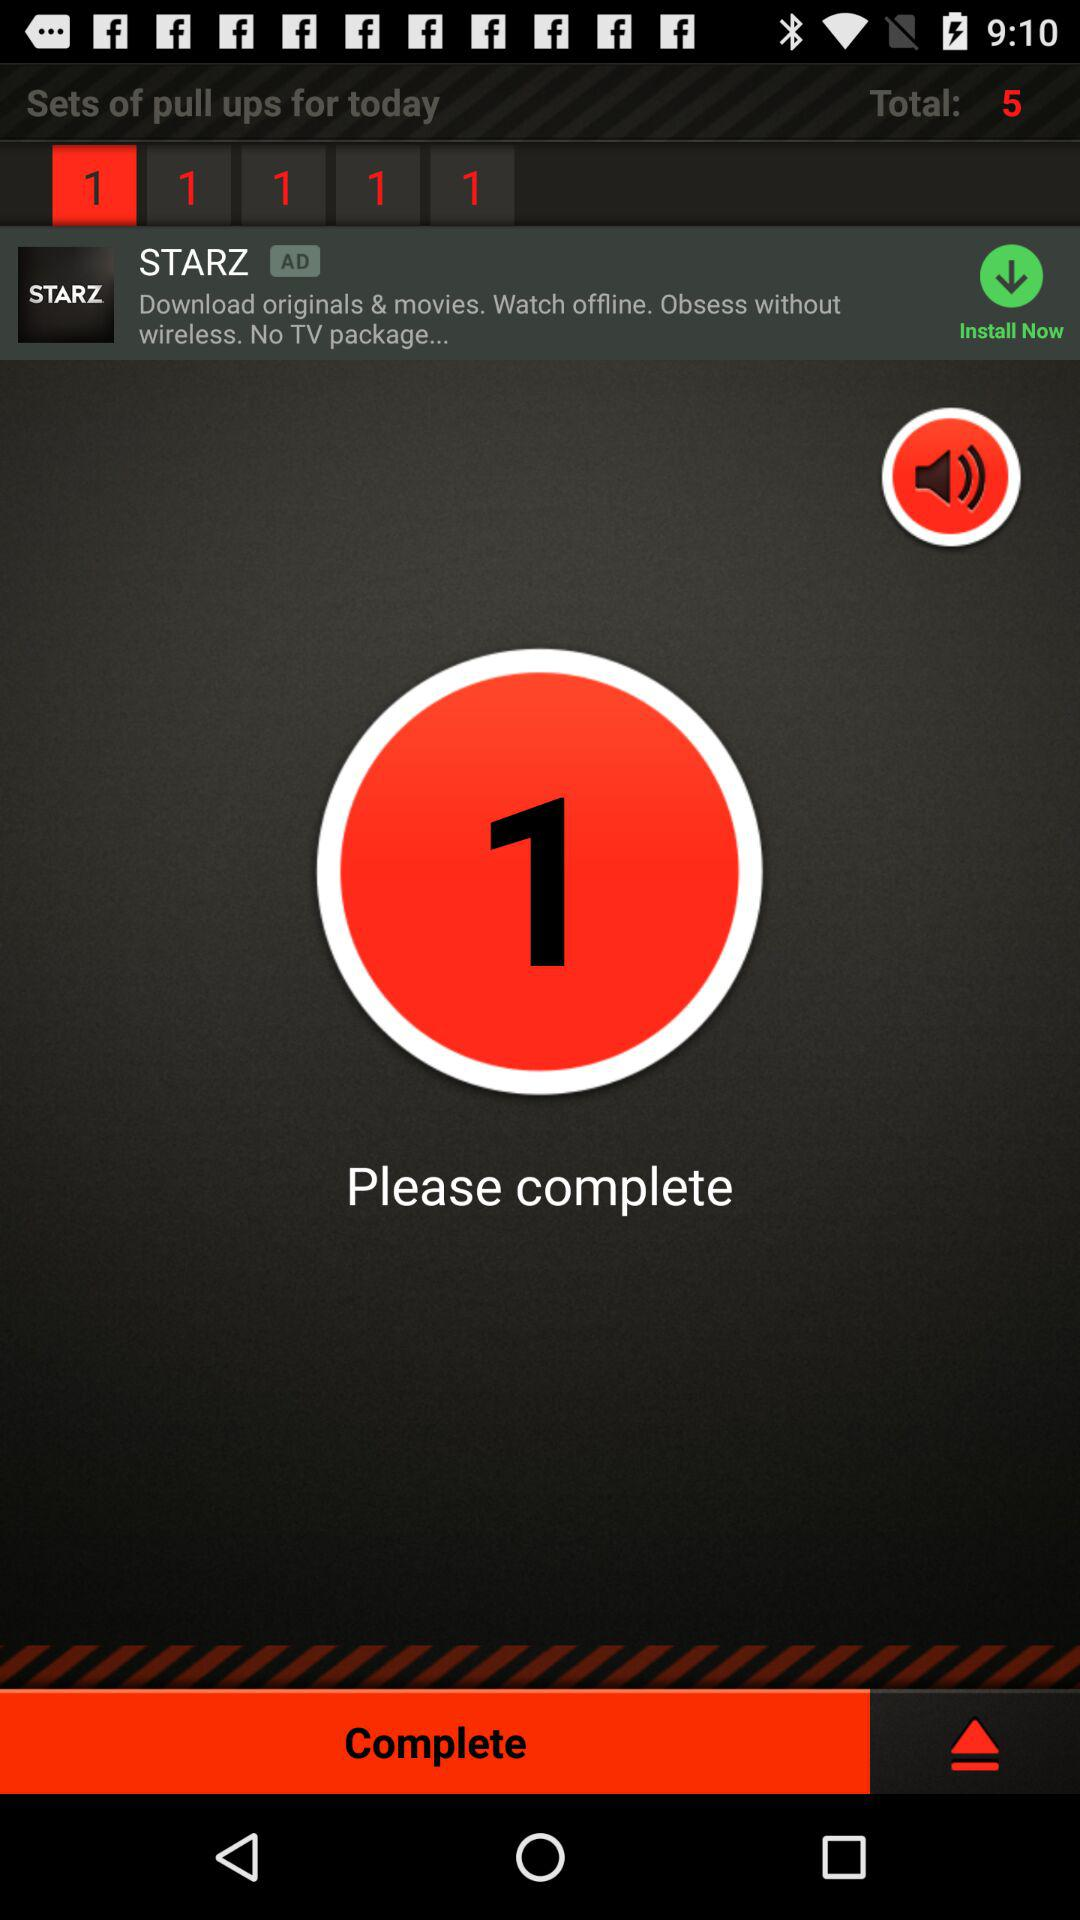What is the total number of sets? The total number of sets is 5. 